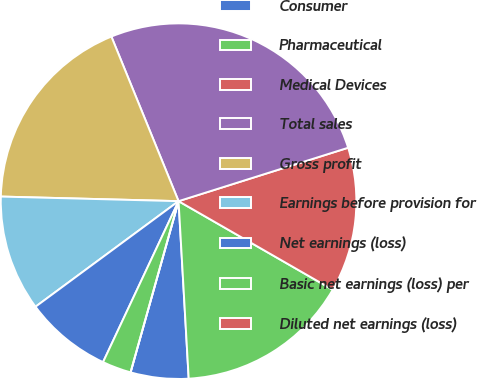Convert chart. <chart><loc_0><loc_0><loc_500><loc_500><pie_chart><fcel>Consumer<fcel>Pharmaceutical<fcel>Medical Devices<fcel>Total sales<fcel>Gross profit<fcel>Earnings before provision for<fcel>Net earnings (loss)<fcel>Basic net earnings (loss) per<fcel>Diluted net earnings (loss)<nl><fcel>5.26%<fcel>15.79%<fcel>13.16%<fcel>26.31%<fcel>18.42%<fcel>10.53%<fcel>7.9%<fcel>2.63%<fcel>0.0%<nl></chart> 